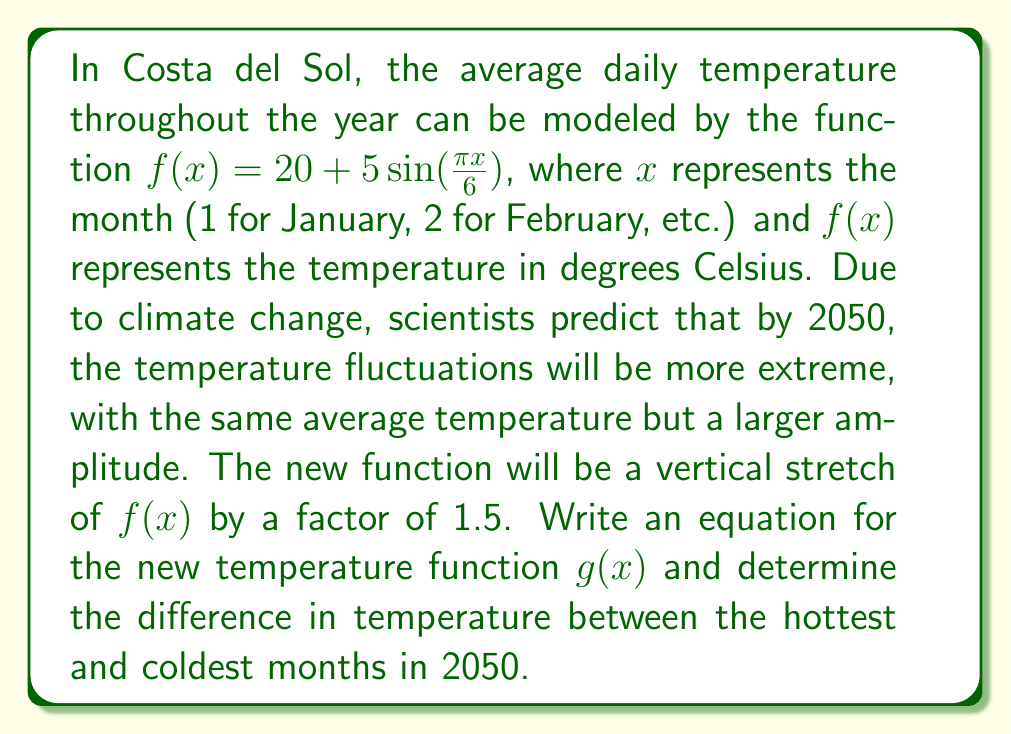Give your solution to this math problem. Let's approach this step-by-step:

1) The original function is $f(x) = 20 + 5\sin(\frac{\pi x}{6})$

2) To create a vertical stretch by a factor of 1.5, we multiply the variable part of the function by 1.5:

   $g(x) = 20 + 1.5(5\sin(\frac{\pi x}{6}))$

3) Simplify:
   
   $g(x) = 20 + 7.5\sin(\frac{\pi x}{6})$

4) To find the difference between the hottest and coldest months, we need to find the maximum and minimum values of $g(x)$

5) The sine function oscillates between -1 and 1, so:

   Maximum: $20 + 7.5(1) = 27.5°C$
   Minimum: $20 + 7.5(-1) = 12.5°C$

6) The difference between the hottest and coldest months:

   $27.5°C - 12.5°C = 15°C$
Answer: $g(x) = 20 + 7.5\sin(\frac{\pi x}{6})$; $15°C$ 